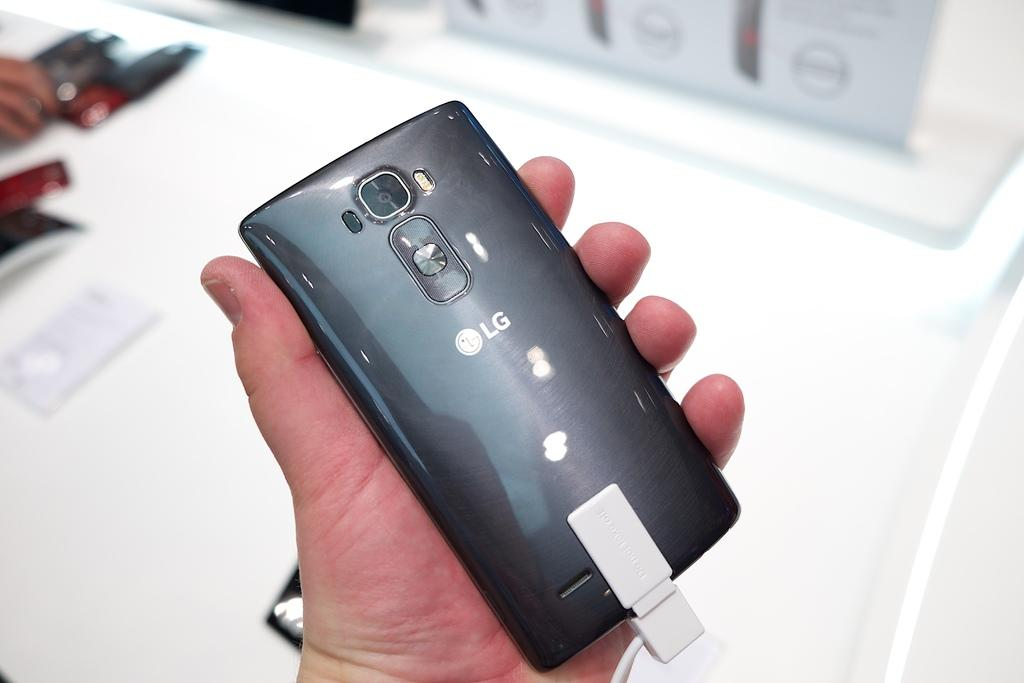<image>
Write a terse but informative summary of the picture. Someone holding a black LG phone in their hand. 